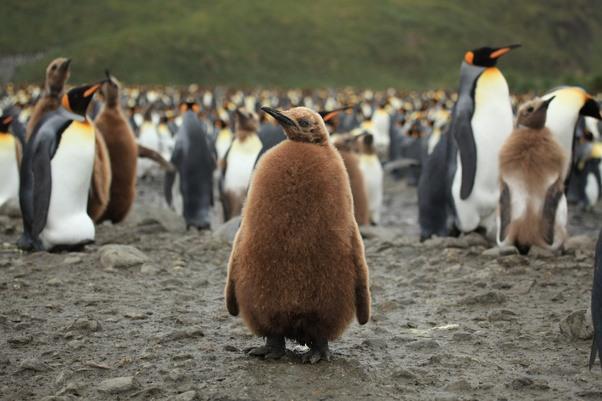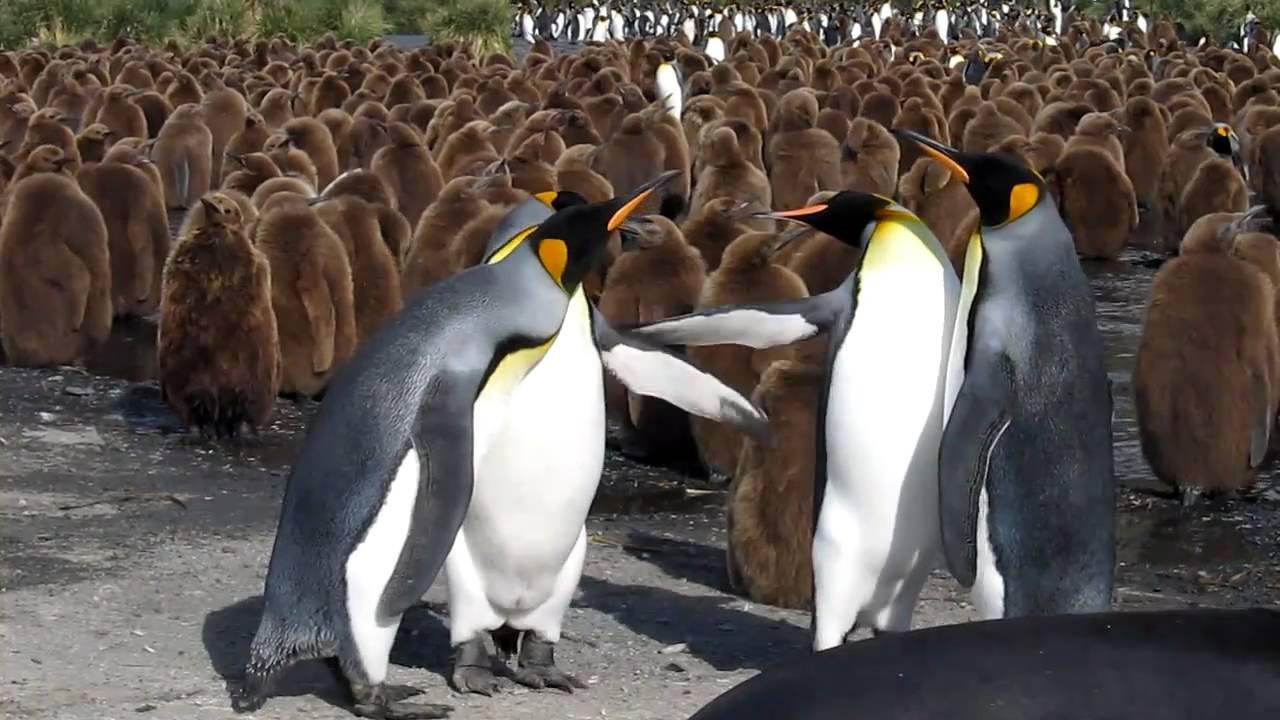The first image is the image on the left, the second image is the image on the right. Given the left and right images, does the statement "An image shows a flock of mostly brown-feathered penguins." hold true? Answer yes or no. Yes. The first image is the image on the left, the second image is the image on the right. For the images displayed, is the sentence "There is less than four penguins in at least one of the images." factually correct? Answer yes or no. No. 